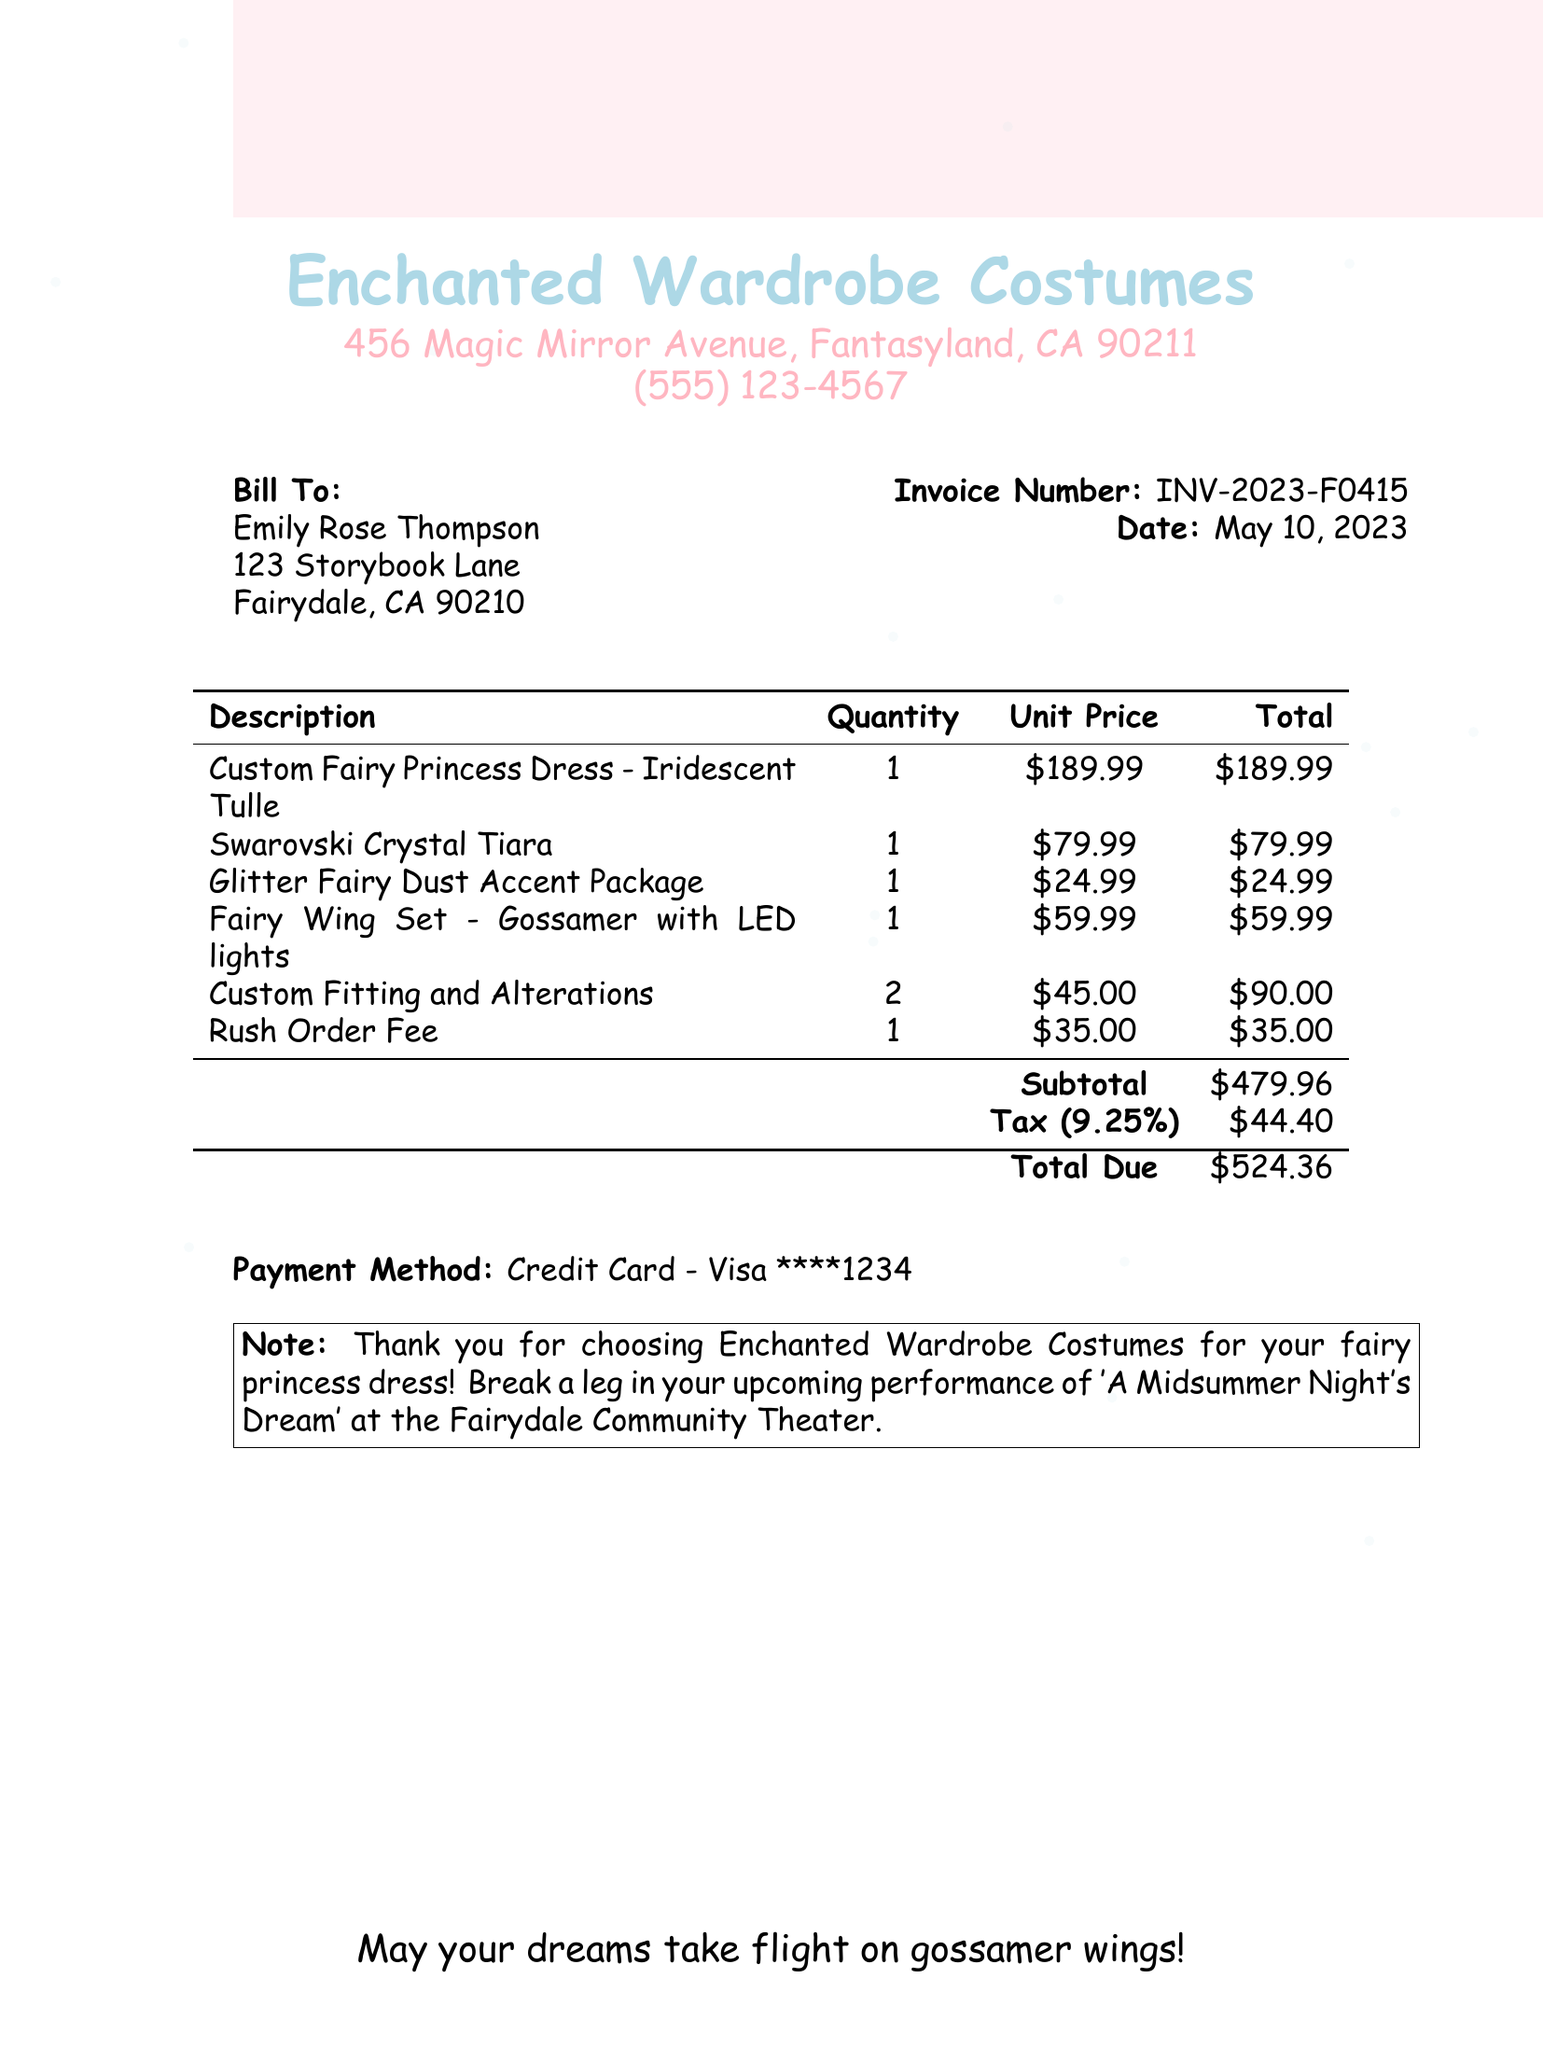What is the invoice number? The invoice number is listed in the document under the invoice details.
Answer: INV-2023-F0415 What date was the invoice created? The date of the invoice is specified in the document.
Answer: May 10, 2023 Who is the customer? The customer's name is mentioned at the beginning of the document.
Answer: Emily Rose Thompson What is the subtotal amount? The subtotal is calculated from the total prices of the items listed.
Answer: $479.96 How many items were custom-fitted? The document specifies the quantity for custom fitting and alterations.
Answer: 2 What is the total due amount? The total due is the final amount to be paid, as listed at the bottom of the invoice.
Answer: $524.36 What is the rush order fee? The rush order fee is listed as one of the charges in the item section.
Answer: $35.00 What type of payment method was used? The payment method is mentioned at the end of the document.
Answer: Credit Card - Visa ****1234 What is the note in the invoice? The note includes a message thanking the customer and wishing them luck.
Answer: Thank you for choosing Enchanted Wardrobe Costumes for your fairy princess dress! Break a leg in your upcoming performance of 'A Midsummer Night's Dream' at the Fairydale Community Theater 